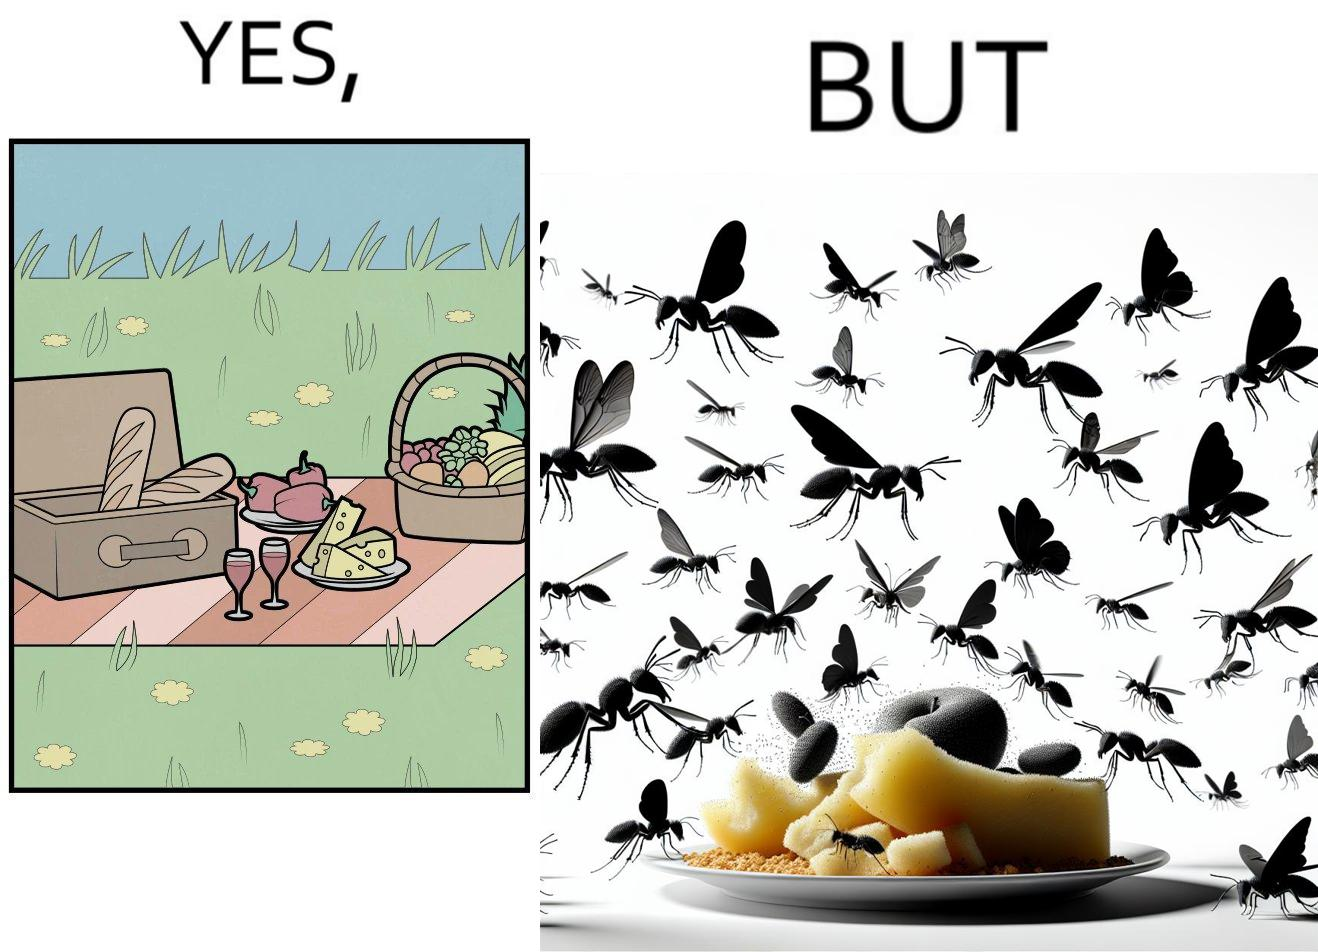What makes this image funny or satirical? The Picture shows that although we enjoy food in garden but there are some consequences of eating food in garden. Many bugs and bees are attracted towards our food and make our food sometimes non-eatable. 